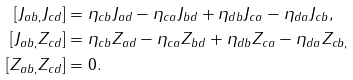<formula> <loc_0><loc_0><loc_500><loc_500>\left [ J _ { a b , } J _ { c d } \right ] & = \eta _ { c b } J _ { a d } - \eta _ { c a } J _ { b d } + \eta _ { d b } J _ { c a } - \eta _ { d a } J _ { c b } , \\ \left [ J _ { a b , } Z _ { c d } \right ] & = \eta _ { c b } Z _ { a d } - \eta _ { c a } Z _ { b d } + \eta _ { d b } Z _ { c a } - \eta _ { d a } Z _ { c b , } \\ \left [ Z _ { a b , } Z _ { c d } \right ] & = 0 .</formula> 